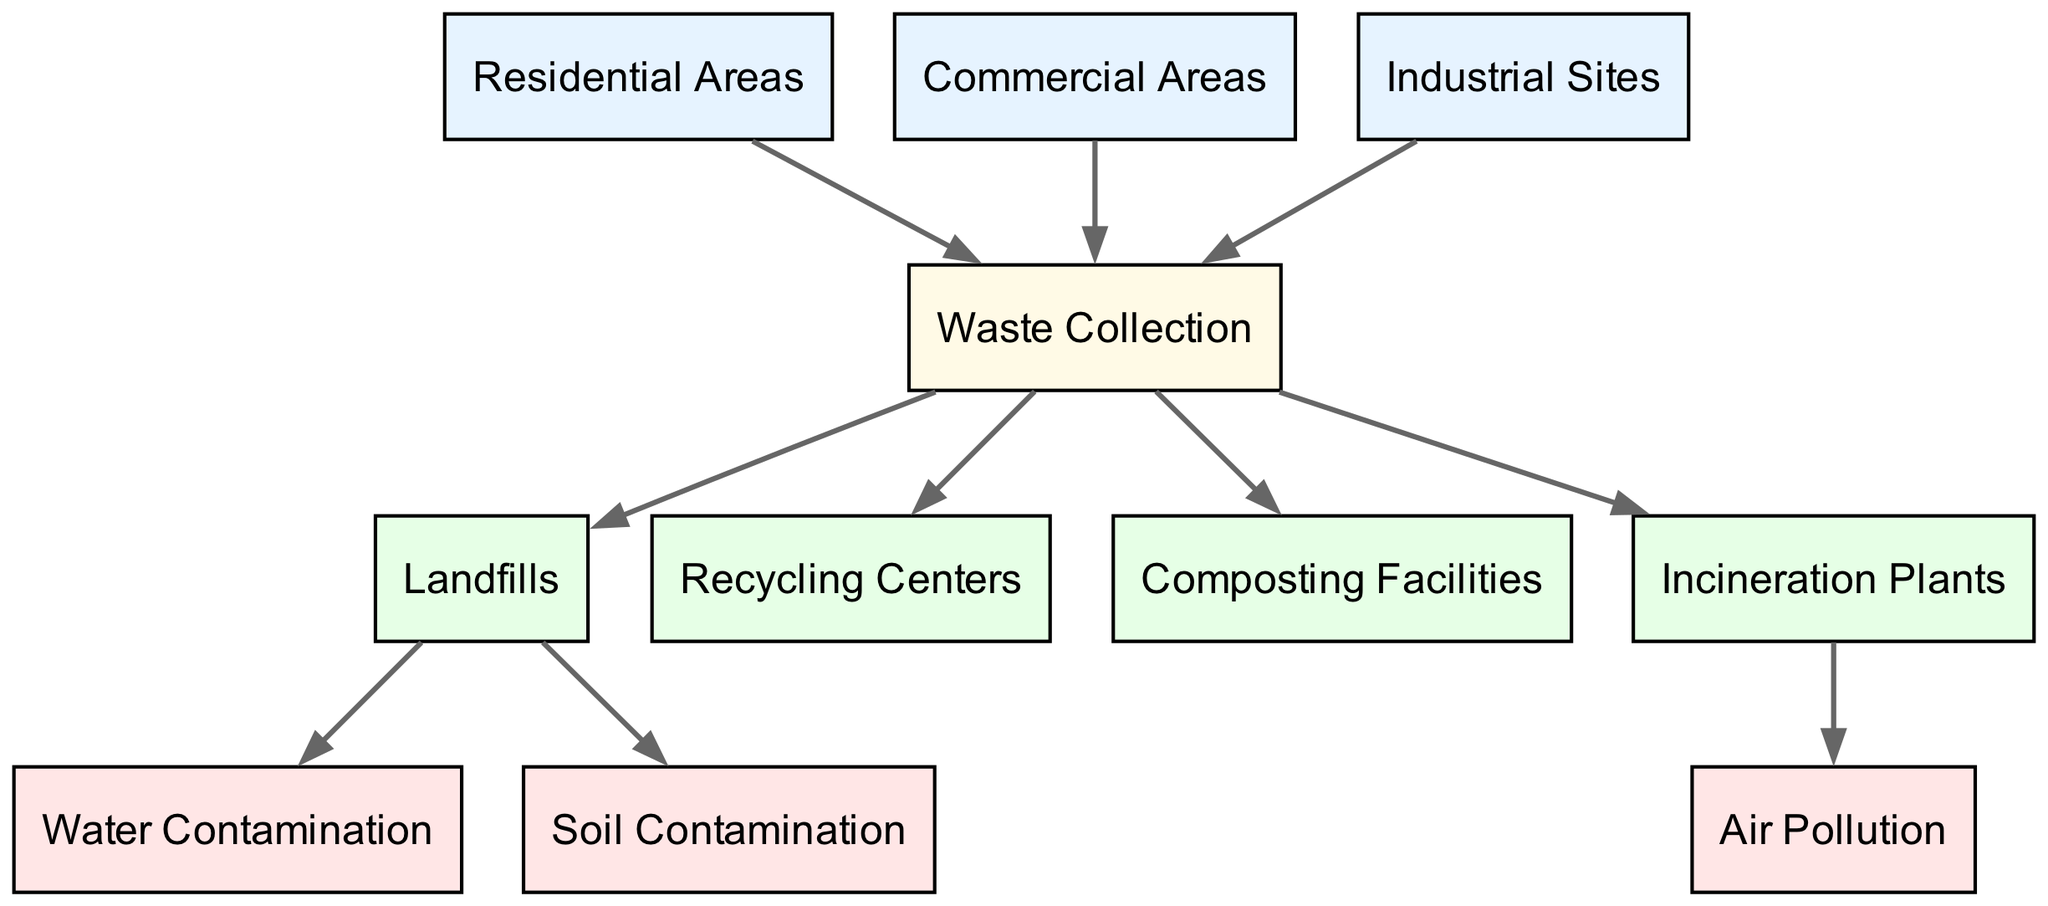What are the sources of waste in urban areas according to the diagram? The diagram identifies three sources of waste: Residential Areas, Commercial Areas, and Industrial Sites. Each of these nodes connects to the Waste Collection process, indicating that waste originates from these areas.
Answer: Residential Areas, Commercial Areas, Industrial Sites How many disposal methods are shown in the diagram? The diagram features four disposal methods: Landfills, Recycling Centers, Composting Facilities, and Incineration Plants. Each of these nodes connects to the Waste Collection process, signifying the various routes for waste disposal.
Answer: Four What is the consequence of waste in Landfills according to the diagram? The diagram indicates that Landfills are linked to two environmental consequences: Water Contamination and Soil Contamination. These connections demonstrate the negative impact of waste disposal in Landfills on the environment.
Answer: Water Contamination, Soil Contamination Which disposal method leads to Air Pollution? The diagram indicates that Incineration Plants are connected to Air Pollution. This suggests that the process of incineration contributes to pollution in the air.
Answer: Incineration Plants Which node has the highest number of connecting edges? The Waste Collection node has four connecting edges as it links to all four disposal methods: Landfills, Recycling Centers, Composting Facilities, and Incineration Plants. This indicates that it serves as a central hub for waste management processes.
Answer: Waste Collection What connects Residential Areas to Waste Collection? The diagram shows a direct connection (edge) from Residential Areas to Waste Collection, indicating that waste generated from residential areas is collected through this process.
Answer: Waste Collection Which type of areas contributes waste to Waste Collection? Three types of areas contribute waste to Waste Collection: Residential Areas, Commercial Areas, and Industrial Sites. These nodes are all linked to Waste Collection, indicating their roles in generating waste.
Answer: Residential Areas, Commercial Areas, Industrial Sites What are the main environmental consequences highlighted in the diagram? The main environmental consequences indicated in the diagram are Water Contamination, Air Pollution, and Soil Contamination. Each of these nodes is linked to corresponding disposal methods, reflecting the environmental impact of waste management practices.
Answer: Water Contamination, Air Pollution, Soil Contamination How many nodes represent disposal methods in total? The diagram includes four nodes that specifically represent disposal methods: Landfills, Recycling Centers, Composting Facilities, and Incineration Plants. This totals to four nodes focused on disposal practices.
Answer: Four 